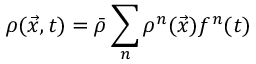<formula> <loc_0><loc_0><loc_500><loc_500>\rho ( \vec { x } , t ) = \bar { \rho } \sum _ { n } \rho ^ { n } ( \vec { x } ) f ^ { n } ( t )</formula> 